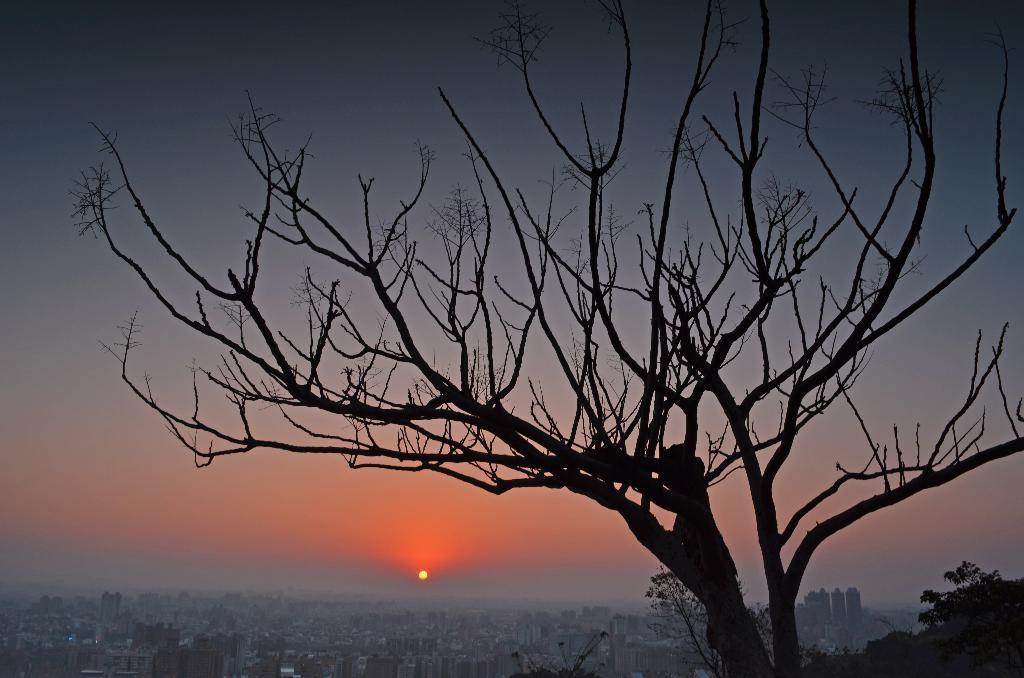Please provide a concise description of this image. In this image I can see sunset, buildings, trees and sky. 